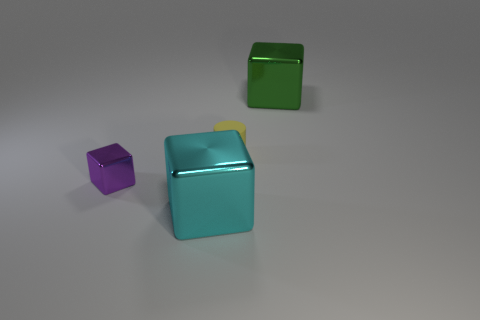Can you describe the shapes and their positions relative to each other? In the image, you can see three geometric shapes: a small purple cube, a larger turquoise cube, and a green cube-shaped frame. The small purple cube is positioned to the left and slightly in front of the larger turquoise cube which has a yellow detail on top. The green cube frame is in the background, slightly elevated and to the right of the larger cube. 